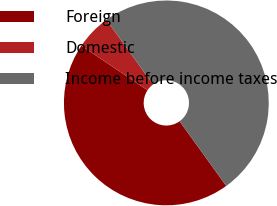Convert chart to OTSL. <chart><loc_0><loc_0><loc_500><loc_500><pie_chart><fcel>Foreign<fcel>Domestic<fcel>Income before income taxes<nl><fcel>44.37%<fcel>5.63%<fcel>50.0%<nl></chart> 